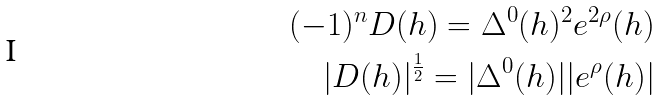Convert formula to latex. <formula><loc_0><loc_0><loc_500><loc_500>( - 1 ) ^ { n } D ( h ) = \Delta ^ { 0 } ( h ) ^ { 2 } e ^ { 2 \rho } ( h ) \\ | D ( h ) | ^ { \frac { 1 } { 2 } } = | \Delta ^ { 0 } ( h ) | | e ^ { \rho } ( h ) |</formula> 